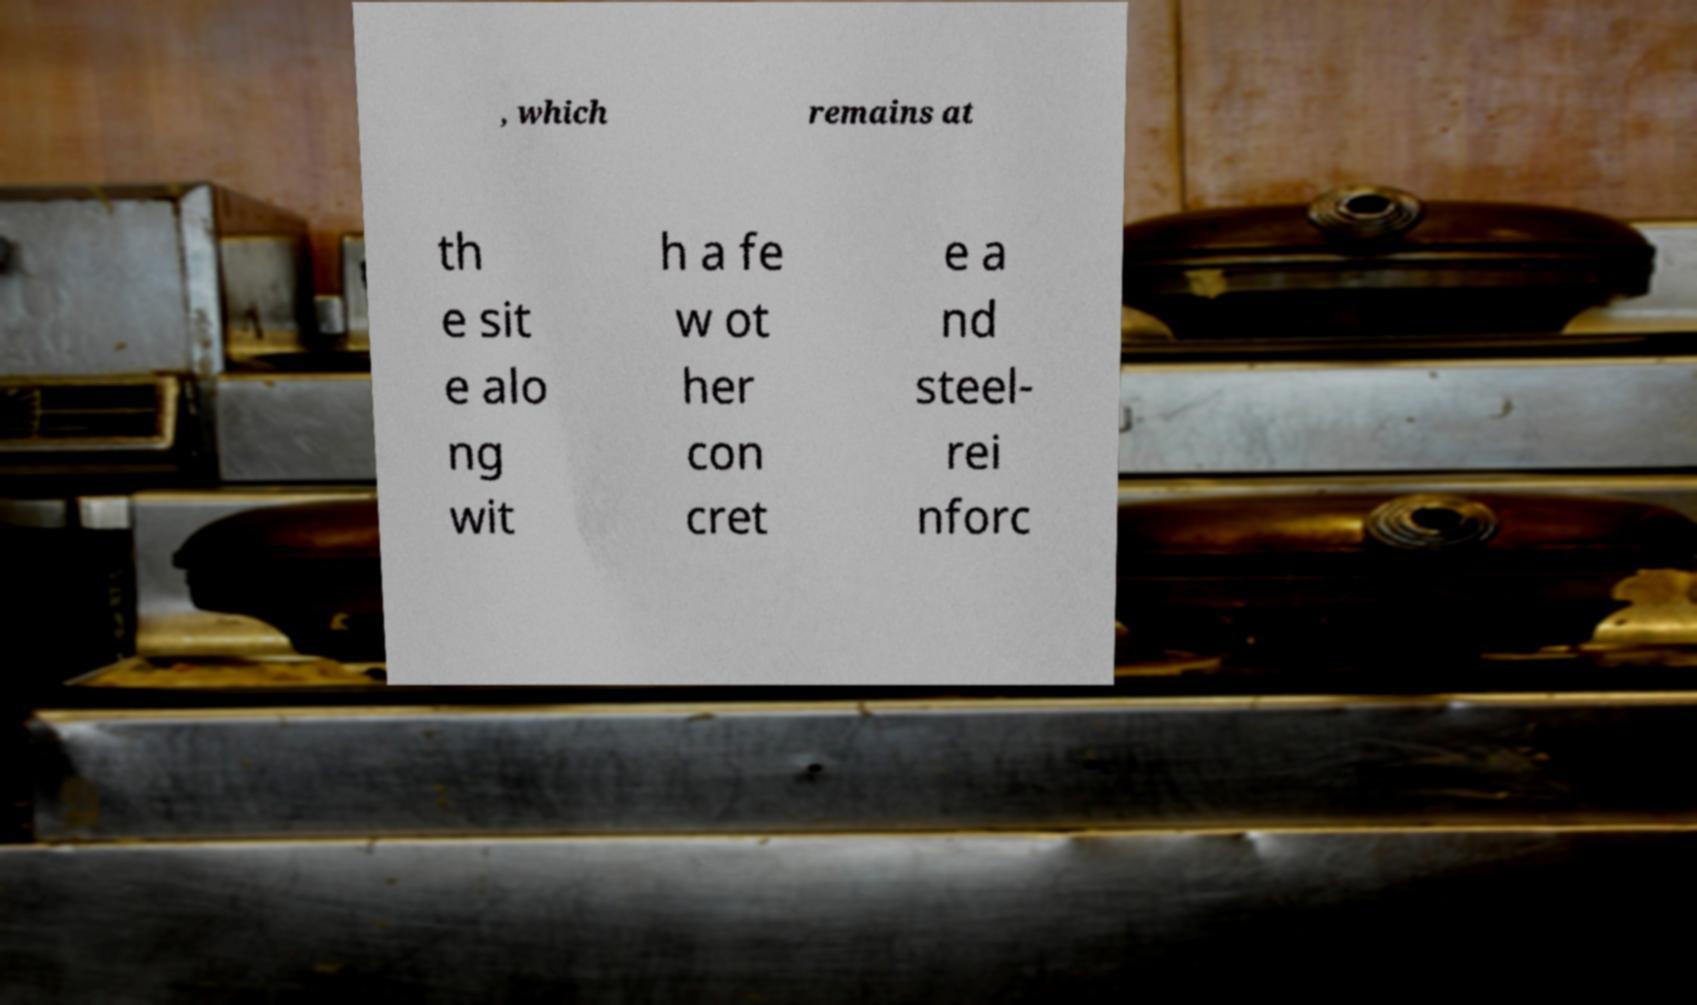What messages or text are displayed in this image? I need them in a readable, typed format. , which remains at th e sit e alo ng wit h a fe w ot her con cret e a nd steel- rei nforc 